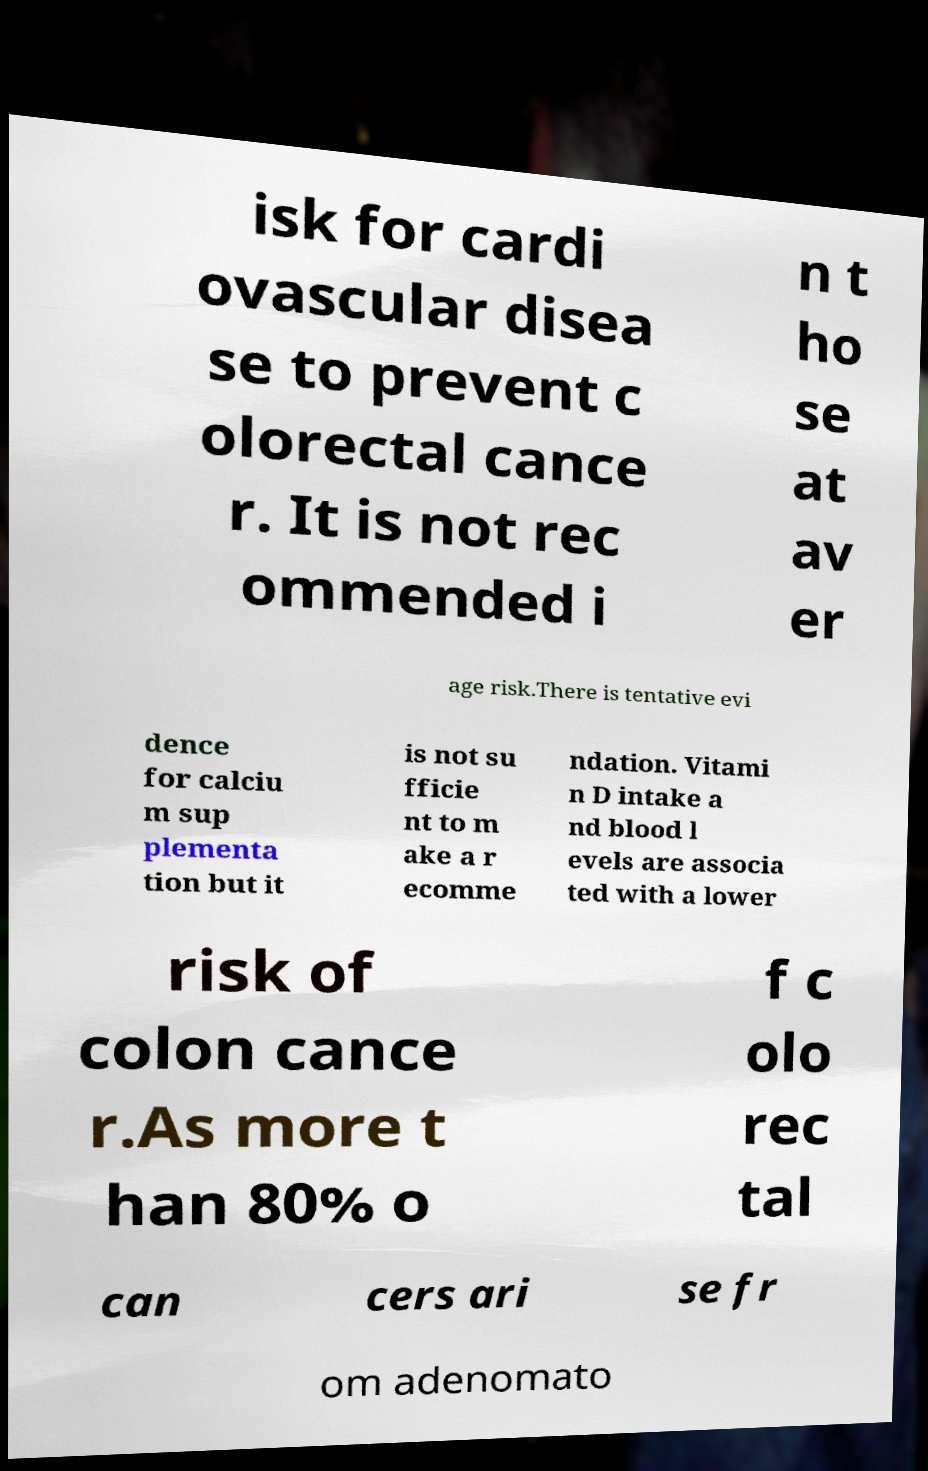For documentation purposes, I need the text within this image transcribed. Could you provide that? isk for cardi ovascular disea se to prevent c olorectal cance r. It is not rec ommended i n t ho se at av er age risk.There is tentative evi dence for calciu m sup plementa tion but it is not su fficie nt to m ake a r ecomme ndation. Vitami n D intake a nd blood l evels are associa ted with a lower risk of colon cance r.As more t han 80% o f c olo rec tal can cers ari se fr om adenomato 